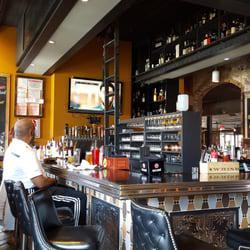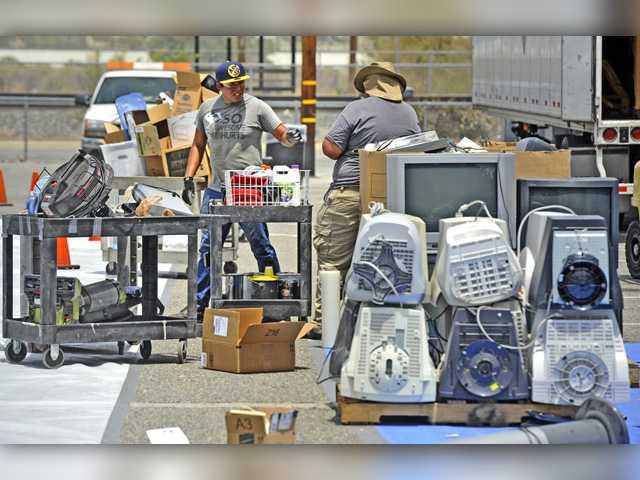The first image is the image on the left, the second image is the image on the right. Assess this claim about the two images: "An image shows TV-type appliances piled in a room in front of pattered wallpaper.". Correct or not? Answer yes or no. No. 